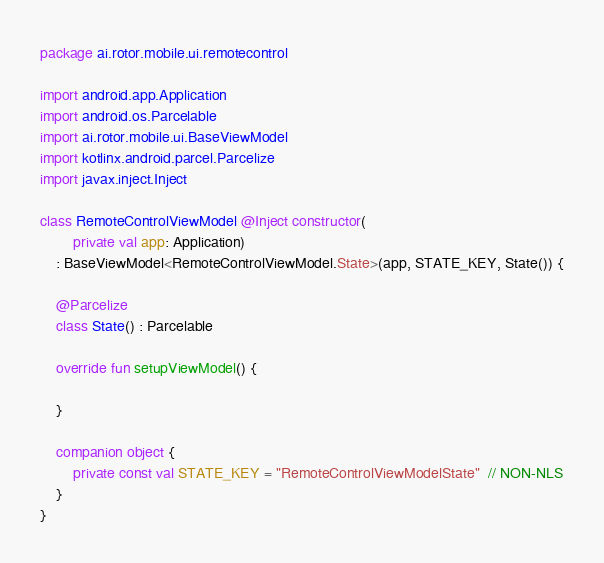<code> <loc_0><loc_0><loc_500><loc_500><_Kotlin_>package ai.rotor.mobile.ui.remotecontrol

import android.app.Application
import android.os.Parcelable
import ai.rotor.mobile.ui.BaseViewModel
import kotlinx.android.parcel.Parcelize
import javax.inject.Inject

class RemoteControlViewModel @Inject constructor(
        private val app: Application)
    : BaseViewModel<RemoteControlViewModel.State>(app, STATE_KEY, State()) {

    @Parcelize
    class State() : Parcelable

    override fun setupViewModel() {

    }

    companion object {
        private const val STATE_KEY = "RemoteControlViewModelState"  // NON-NLS
    }
}
</code> 